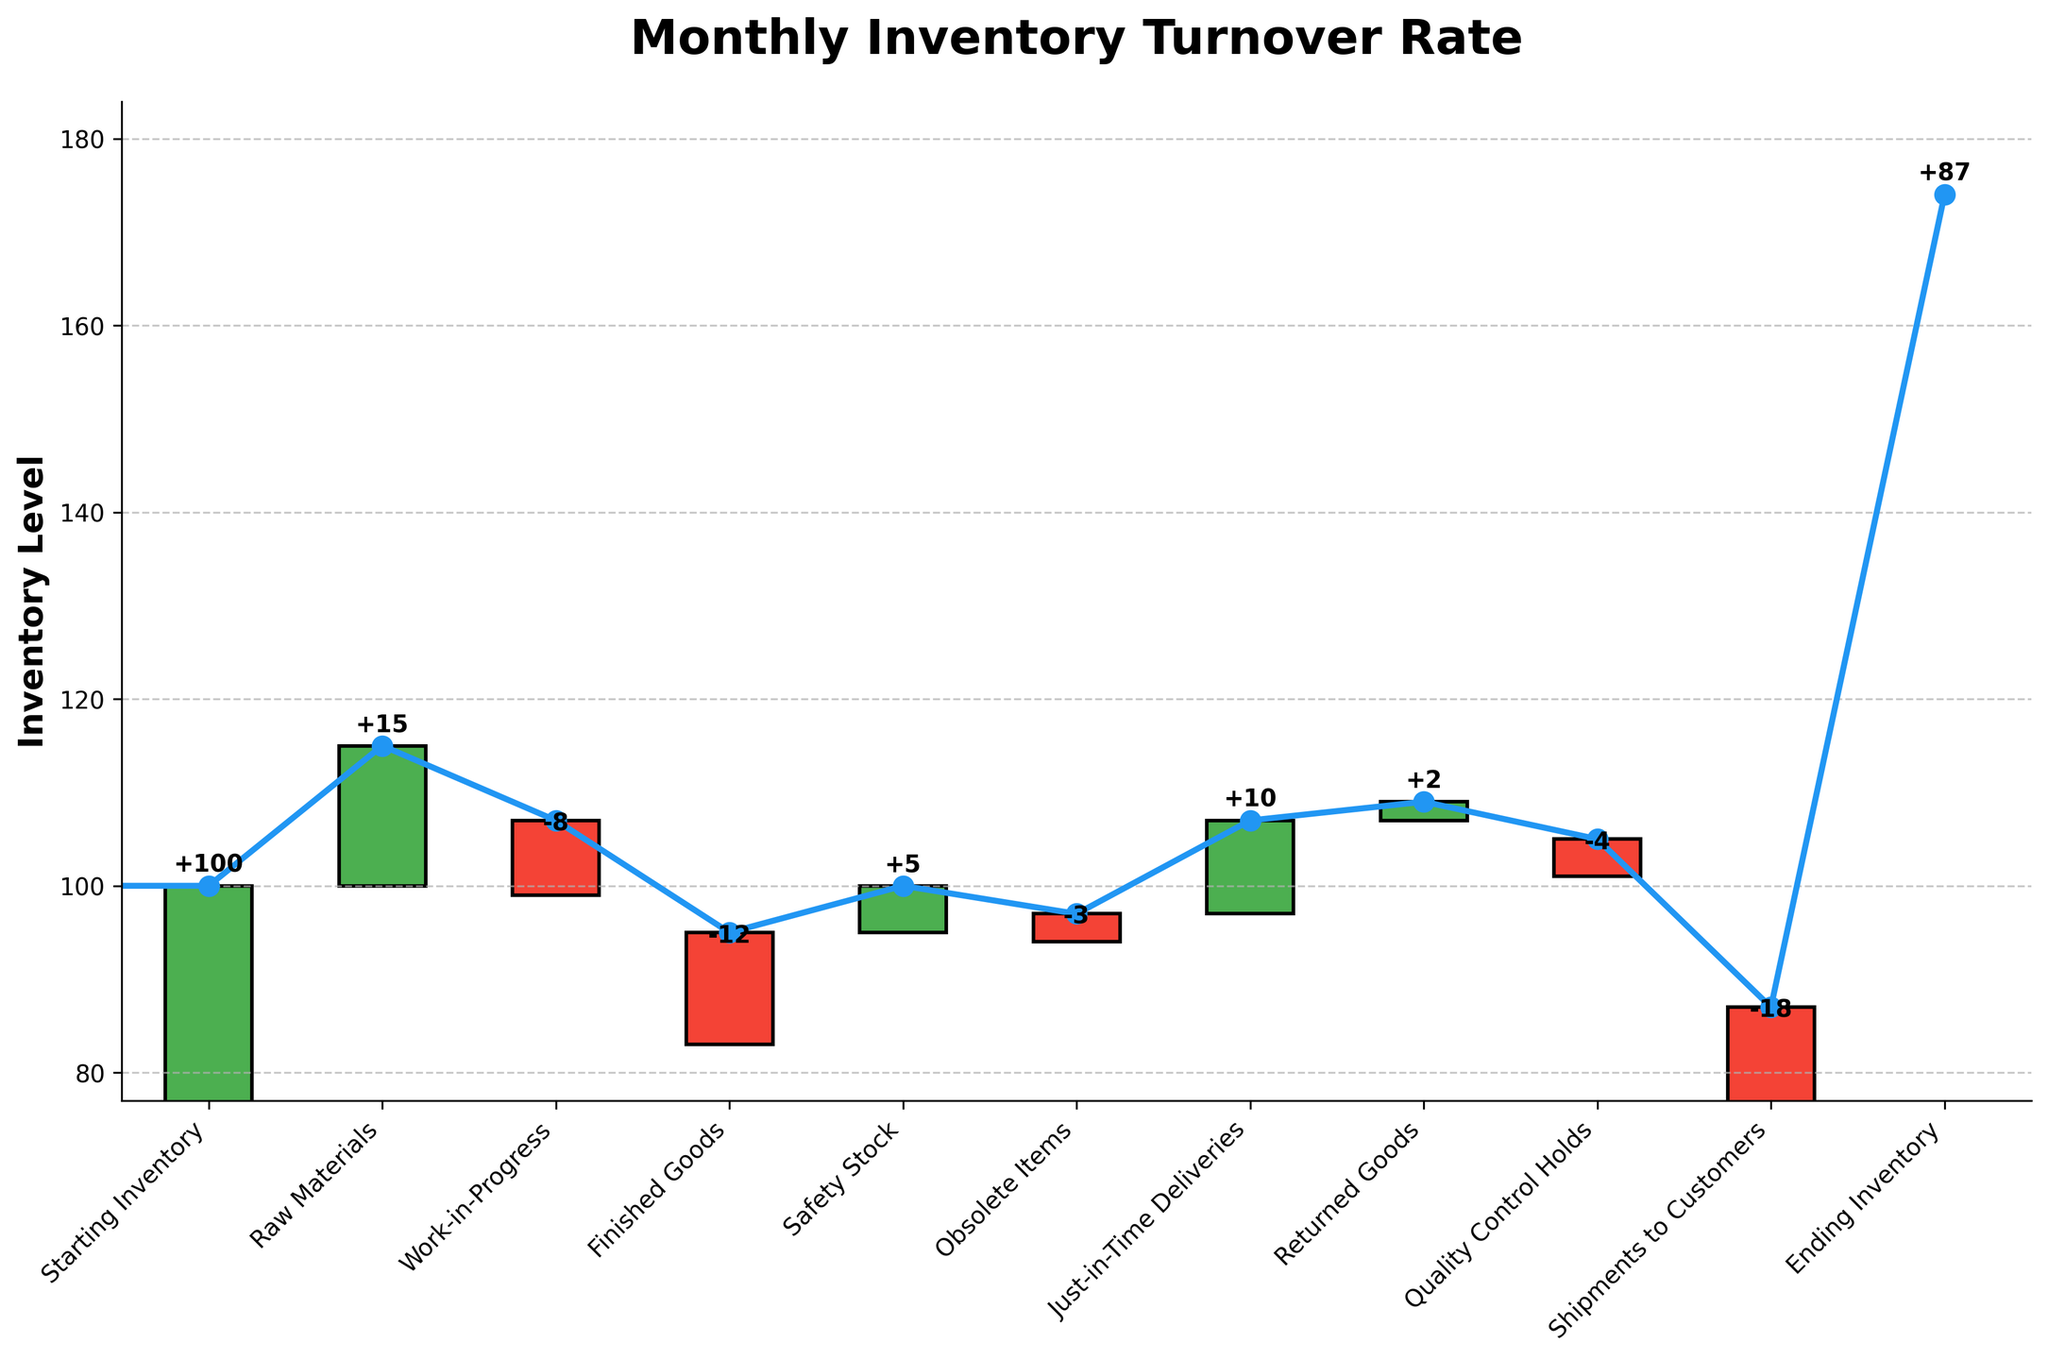What's the title of the chart? The title is located at the top of the chart and provides a quick summary of the chart's content. It reads "Monthly Inventory Turnover Rate".
Answer: Monthly Inventory Turnover Rate How many categories are displayed on the x-axis? The x-axis labels represent each category in the inventory process. Counting the labels, there are 11 categories, starting from "Starting Inventory" to "Ending Inventory".
Answer: 11 What is the value for Raw Materials? Locate the bar corresponding to "Raw Materials" on the x-axis. The label and the top of the green bar indicate it has a value of +15, which is also annotated on the bar itself.
Answer: +15 What are the cumulative changes in inventory after Finished Goods? The cumulative change is the sum of the starting inventory and all subsequent changes up to and including Finished Goods. Calculating it step-by-step: 100 (Starting Inventory) + 15 (Raw Materials) - 8 (Work-in-Progress) - 12 (Finished Goods). This results in 95.
Answer: 95 Which category had the greatest negative impact on inventory levels? To find the greatest negative impact, look for the largest red bar, which represents negative values. The bar labeled "Shipments to Customers" has the highest negative value of -18.
Answer: Shipments to Customers How does Ending Inventory compare to Starting Inventory? Compare the cumulative value at the start and end of the chart. Starting Inventory is 100, and Ending Inventory is 87. The Ending Inventory is 13 units less than the Starting Inventory.
Answer: 13 units less What is the overall change in inventory from start to end? Calculate the difference between Ending Inventory and Starting Inventory. Starting Inventory is 100 and Ending Inventory is 87, so the overall change is 87 - 100.
Answer: -13 What combined effect do Safety Stock and Just-in-Time Deliveries have on inventory levels? Summing the values for Safety Stock and Just-in-Time Deliveries: +5 + 10. Together, they add 15 units to the inventory.
Answer: +15 What is the impact of Quality Control Holds on the inventory levels? Locate the bar for Quality Control Holds, which is red, indicating a negative value. The annotated value is -4.
Answer: -4 What is the net effect of Returned Goods and Obsolete Items combined? Calculate the combined impact by adding the values of Returned Goods and Obsolete Items. +2 (Returned Goods) + (-3) (Obsolete Items) results in -1.
Answer: -1 